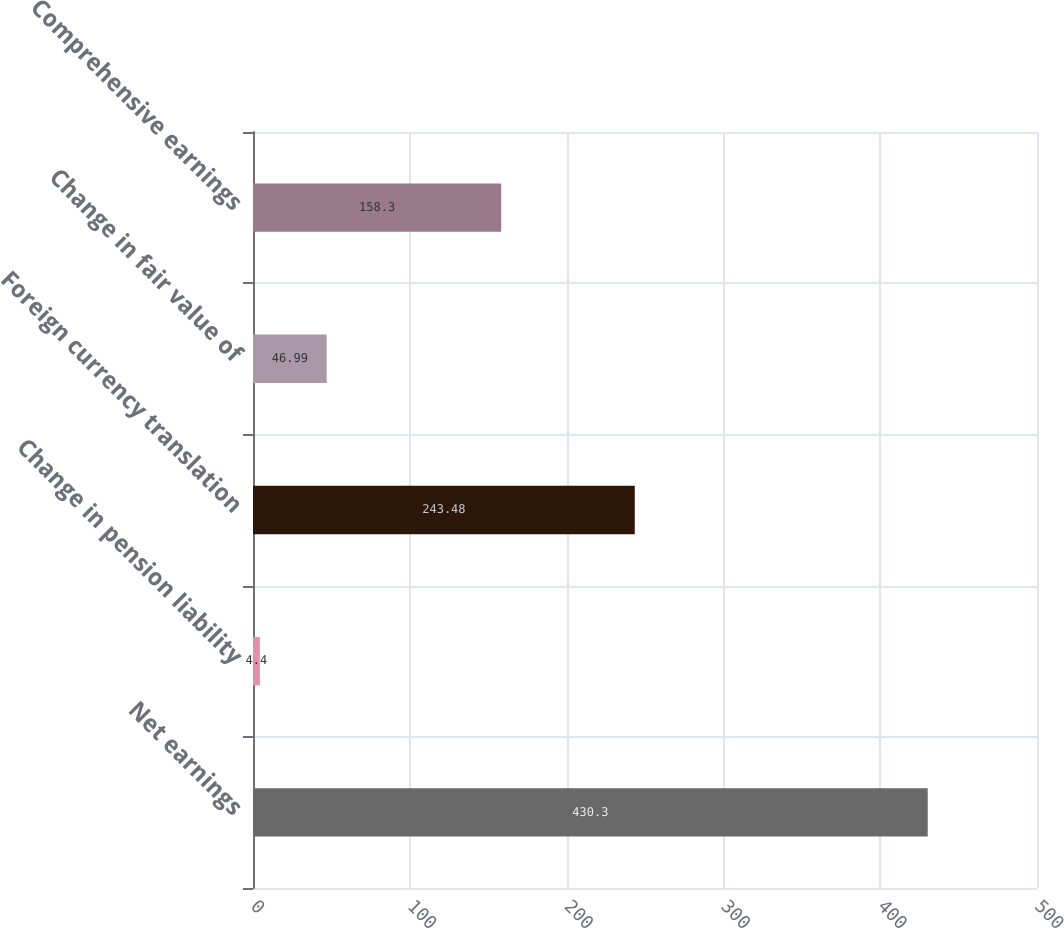Convert chart to OTSL. <chart><loc_0><loc_0><loc_500><loc_500><bar_chart><fcel>Net earnings<fcel>Change in pension liability<fcel>Foreign currency translation<fcel>Change in fair value of<fcel>Comprehensive earnings<nl><fcel>430.3<fcel>4.4<fcel>243.48<fcel>46.99<fcel>158.3<nl></chart> 